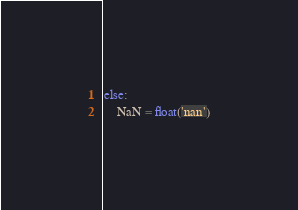Convert code to text. <code><loc_0><loc_0><loc_500><loc_500><_Python_>else:
    NaN = float('nan')
</code> 